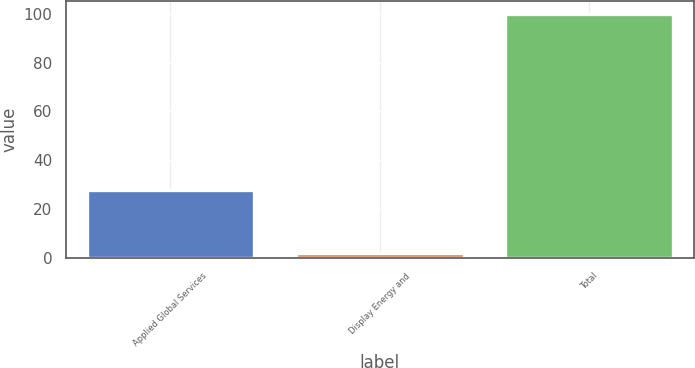<chart> <loc_0><loc_0><loc_500><loc_500><bar_chart><fcel>Applied Global Services<fcel>Display Energy and<fcel>Total<nl><fcel>28<fcel>2<fcel>100<nl></chart> 